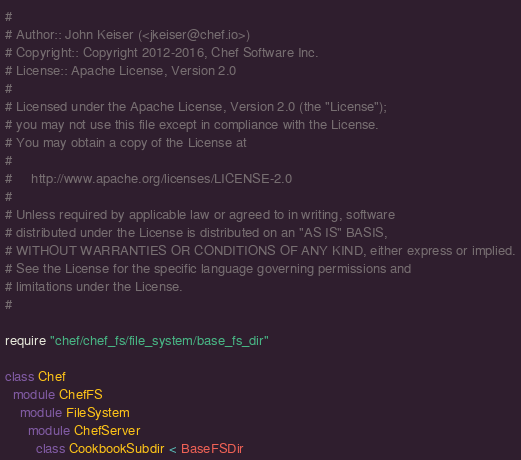Convert code to text. <code><loc_0><loc_0><loc_500><loc_500><_Ruby_>#
# Author:: John Keiser (<jkeiser@chef.io>)
# Copyright:: Copyright 2012-2016, Chef Software Inc.
# License:: Apache License, Version 2.0
#
# Licensed under the Apache License, Version 2.0 (the "License");
# you may not use this file except in compliance with the License.
# You may obtain a copy of the License at
#
#     http://www.apache.org/licenses/LICENSE-2.0
#
# Unless required by applicable law or agreed to in writing, software
# distributed under the License is distributed on an "AS IS" BASIS,
# WITHOUT WARRANTIES OR CONDITIONS OF ANY KIND, either express or implied.
# See the License for the specific language governing permissions and
# limitations under the License.
#

require "chef/chef_fs/file_system/base_fs_dir"

class Chef
  module ChefFS
    module FileSystem
      module ChefServer
        class CookbookSubdir < BaseFSDir</code> 